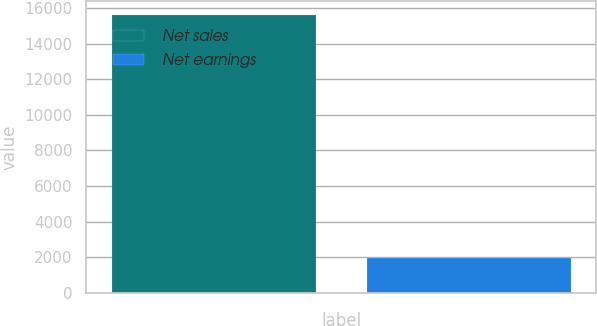Convert chart. <chart><loc_0><loc_0><loc_500><loc_500><bar_chart><fcel>Net sales<fcel>Net earnings<nl><fcel>15606<fcel>1978<nl></chart> 